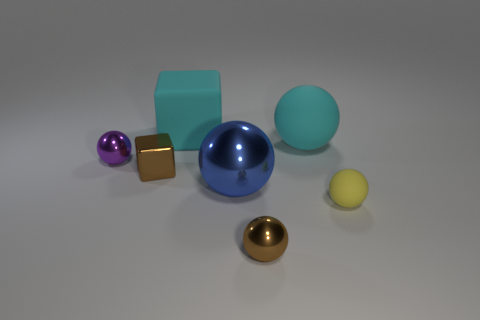Subtract all large balls. How many balls are left? 3 Add 3 small yellow matte cylinders. How many objects exist? 10 Subtract all balls. How many objects are left? 2 Subtract 1 blocks. How many blocks are left? 1 Subtract all red balls. Subtract all green blocks. How many balls are left? 5 Subtract all gray cylinders. How many yellow spheres are left? 1 Subtract all blue spheres. Subtract all large blue objects. How many objects are left? 5 Add 7 purple spheres. How many purple spheres are left? 8 Add 6 yellow shiny cylinders. How many yellow shiny cylinders exist? 6 Subtract all cyan cubes. How many cubes are left? 1 